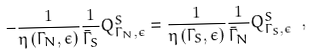<formula> <loc_0><loc_0><loc_500><loc_500>- \frac { 1 } { \eta \left ( \Gamma _ { N } , \epsilon \right ) } \frac { 1 } { \bar { \Gamma } _ { S } } Q ^ { S } _ { \Gamma _ { N } , \epsilon } = \frac { 1 } { \eta \left ( \Gamma _ { S } , \epsilon \right ) } \frac { 1 } { \bar { \Gamma } _ { N } } Q ^ { S } _ { \Gamma _ { S } , \epsilon } \ ,</formula> 